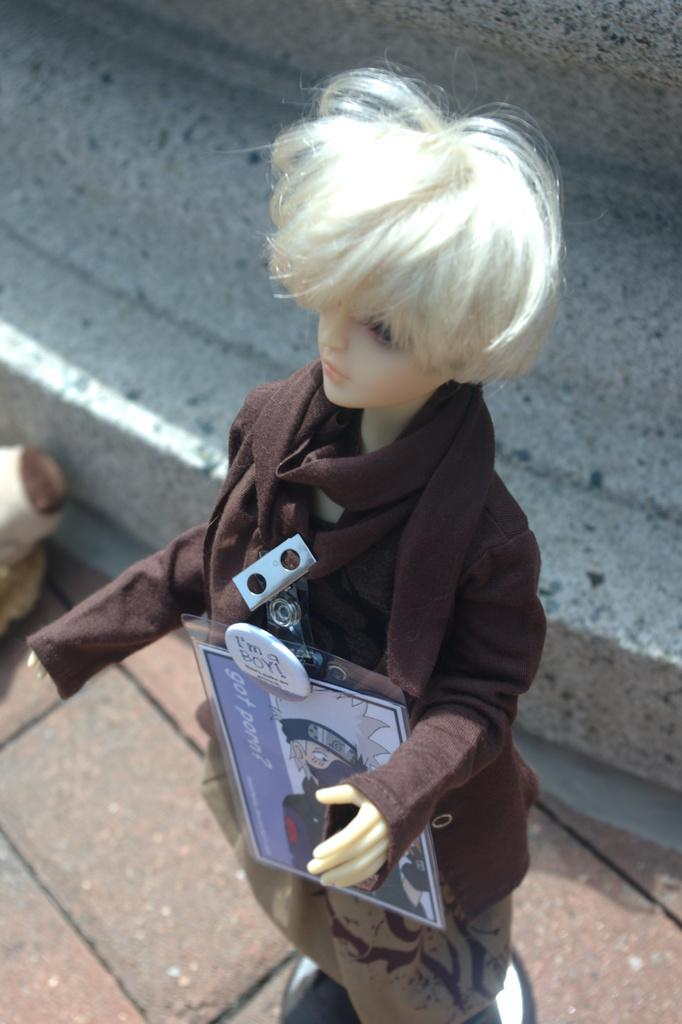What is the main subject of the image? There is a Barbie doll in the image. Where is the Barbie doll placed? The Barbie doll is placed on a wall path. What can be seen in the background of the image? There is a wall in the background of the image. What is the appearance of the wall? The wall has white and black dots on it. What rule is being enforced by the Barbie doll in the image? There is no indication in the image that the Barbie doll is enforcing any rules. 